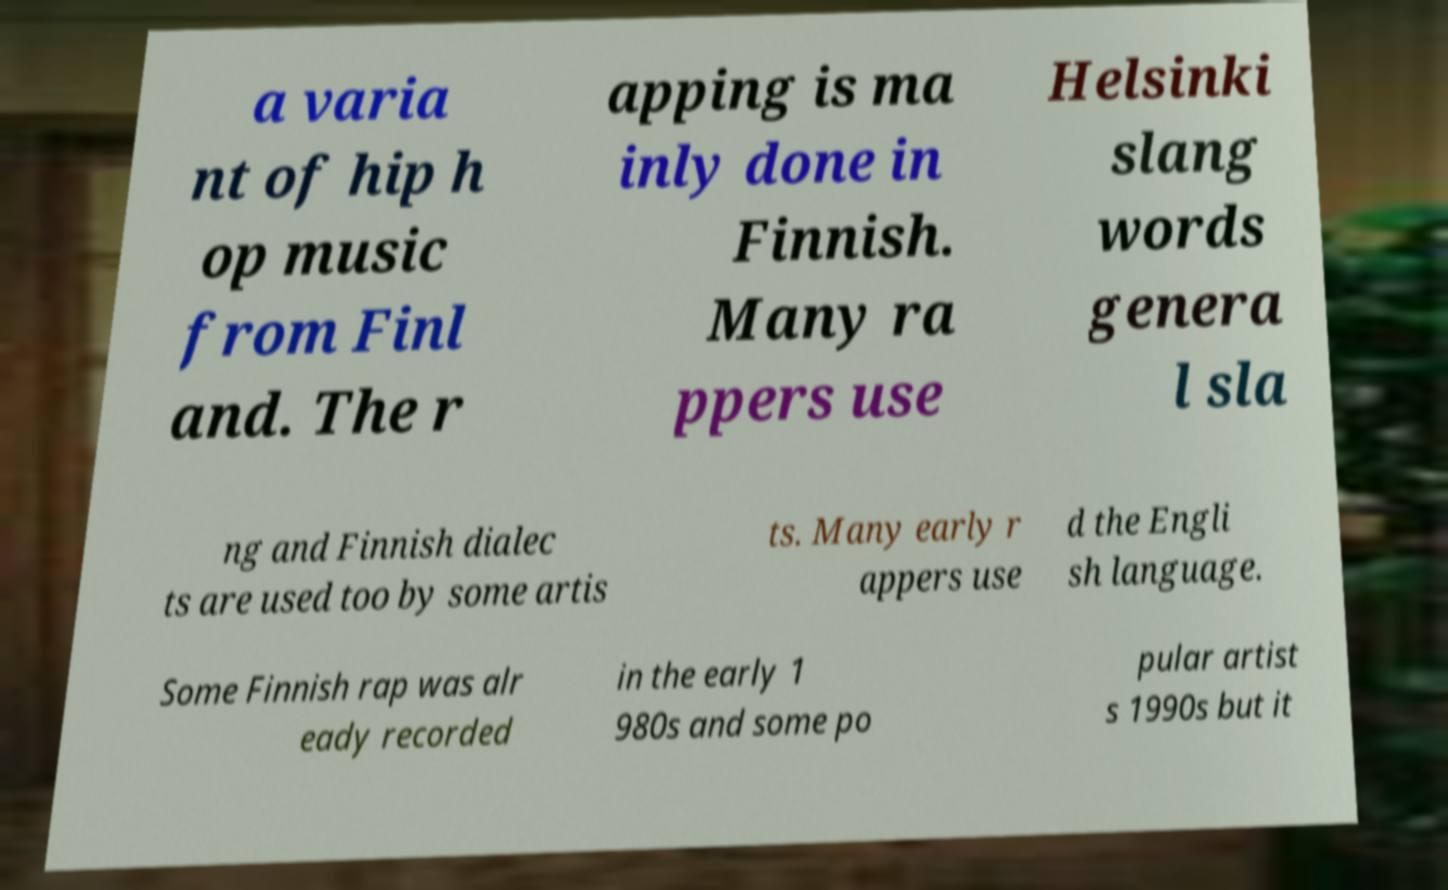Can you read and provide the text displayed in the image?This photo seems to have some interesting text. Can you extract and type it out for me? a varia nt of hip h op music from Finl and. The r apping is ma inly done in Finnish. Many ra ppers use Helsinki slang words genera l sla ng and Finnish dialec ts are used too by some artis ts. Many early r appers use d the Engli sh language. Some Finnish rap was alr eady recorded in the early 1 980s and some po pular artist s 1990s but it 